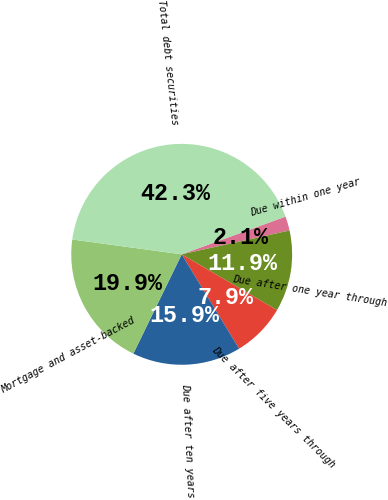Convert chart. <chart><loc_0><loc_0><loc_500><loc_500><pie_chart><fcel>Due within one year<fcel>Due after one year through<fcel>Due after five years through<fcel>Due after ten years<fcel>Mortgage and asset-backed<fcel>Total debt securities<nl><fcel>2.09%<fcel>11.89%<fcel>7.87%<fcel>15.91%<fcel>19.93%<fcel>42.31%<nl></chart> 